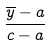Convert formula to latex. <formula><loc_0><loc_0><loc_500><loc_500>\frac { \overline { y } - a } { c - a }</formula> 